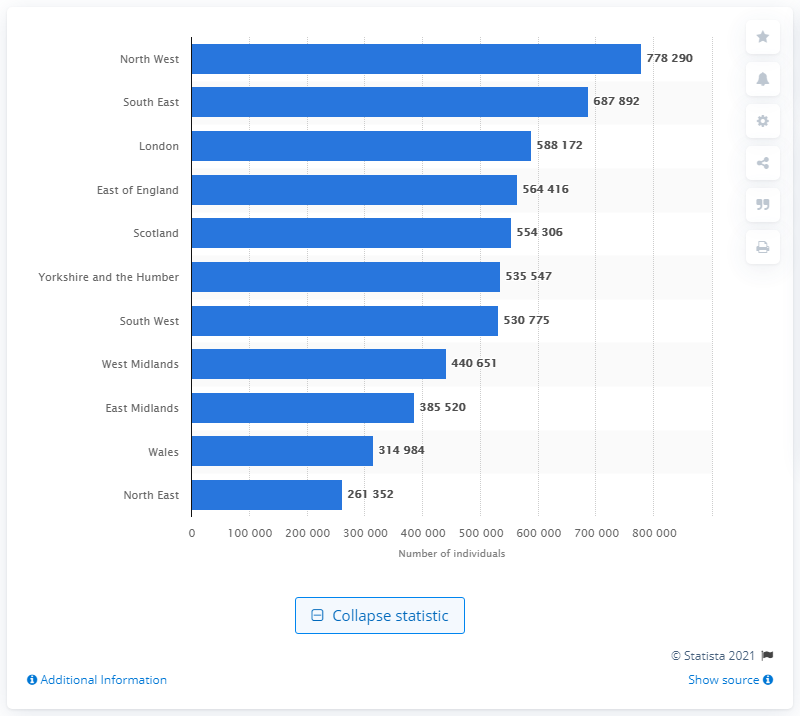Please provide a summary of the statistics shown in the image. The bar chart displays the number of individuals with asthma in different regions of the UK for the year 2015. The North West tops the chart with 778,290 cases, followed closely by the South East with 687,892 cases. The regions with the least cases are Wales and the North East, with 314,984 and 261,352 cases respectively. Overall, the chart illustrates the prevalence of asthma across various regions, showing significant variation in numbers from one region to another. 